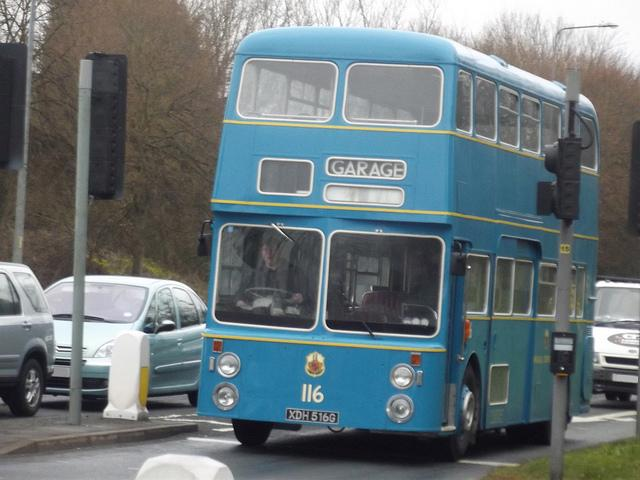Why is the bus without passengers?

Choices:
A) passengers exiting
B) accident
C) garage bound
D) broken down garage bound 